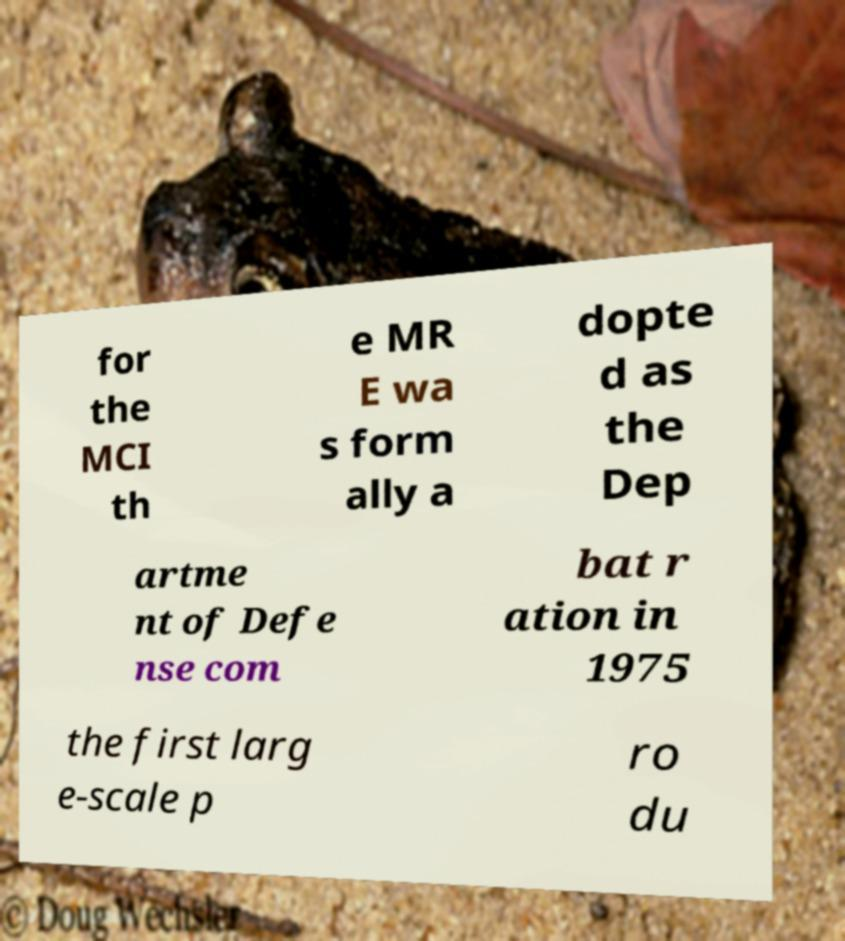For documentation purposes, I need the text within this image transcribed. Could you provide that? for the MCI th e MR E wa s form ally a dopte d as the Dep artme nt of Defe nse com bat r ation in 1975 the first larg e-scale p ro du 